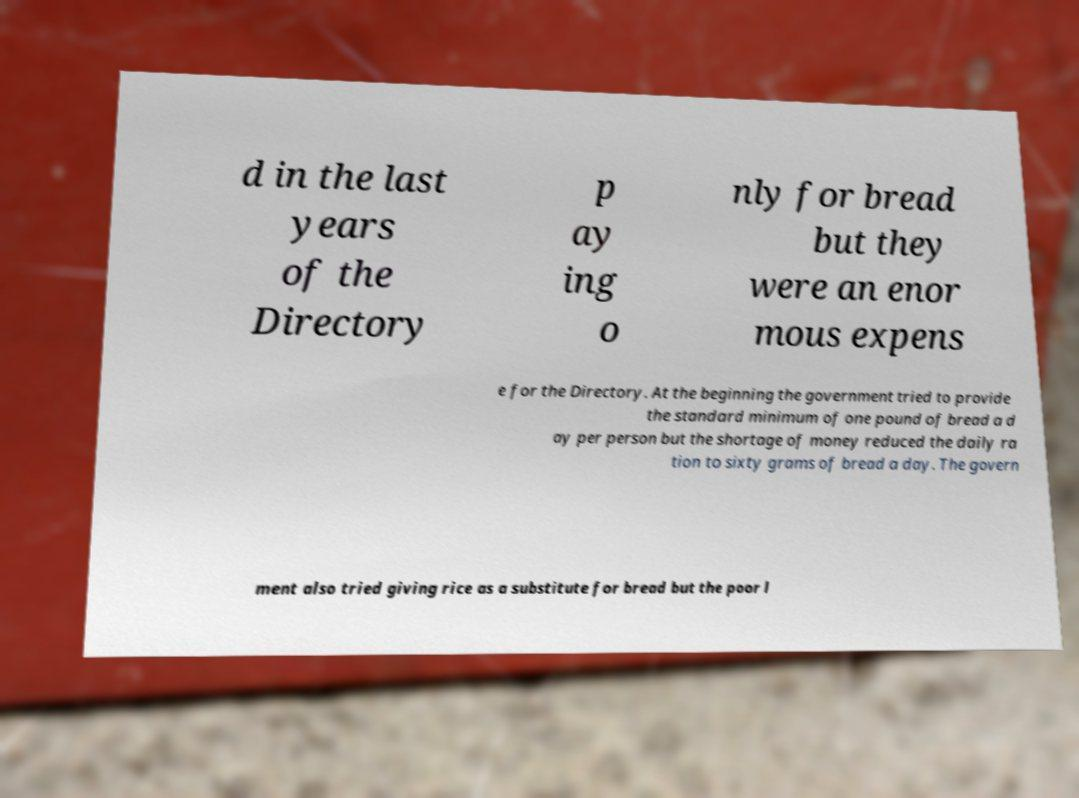What messages or text are displayed in this image? I need them in a readable, typed format. d in the last years of the Directory p ay ing o nly for bread but they were an enor mous expens e for the Directory. At the beginning the government tried to provide the standard minimum of one pound of bread a d ay per person but the shortage of money reduced the daily ra tion to sixty grams of bread a day. The govern ment also tried giving rice as a substitute for bread but the poor l 